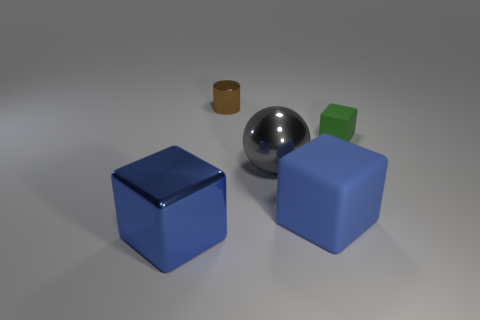What number of objects are either rubber cubes left of the small matte block or blue blocks on the right side of the brown metal object?
Your answer should be very brief. 1. Is the number of large rubber objects less than the number of green metal things?
Offer a very short reply. No. What number of objects are small green things or big blue rubber blocks?
Make the answer very short. 2. Do the tiny matte object and the big rubber object have the same shape?
Offer a very short reply. Yes. Does the blue object that is on the left side of the tiny metallic object have the same size as the rubber block that is behind the big metallic sphere?
Your response must be concise. No. What is the thing that is behind the big gray thing and to the left of the big gray sphere made of?
Your answer should be very brief. Metal. Is there anything else of the same color as the big shiny cube?
Make the answer very short. Yes. Is the number of tiny brown shiny cylinders right of the cylinder less than the number of green matte cubes?
Provide a succinct answer. Yes. Is the number of tiny brown spheres greater than the number of tiny metal things?
Make the answer very short. No. Is there a large metallic thing that is behind the blue block that is behind the object in front of the blue matte cube?
Keep it short and to the point. Yes. 